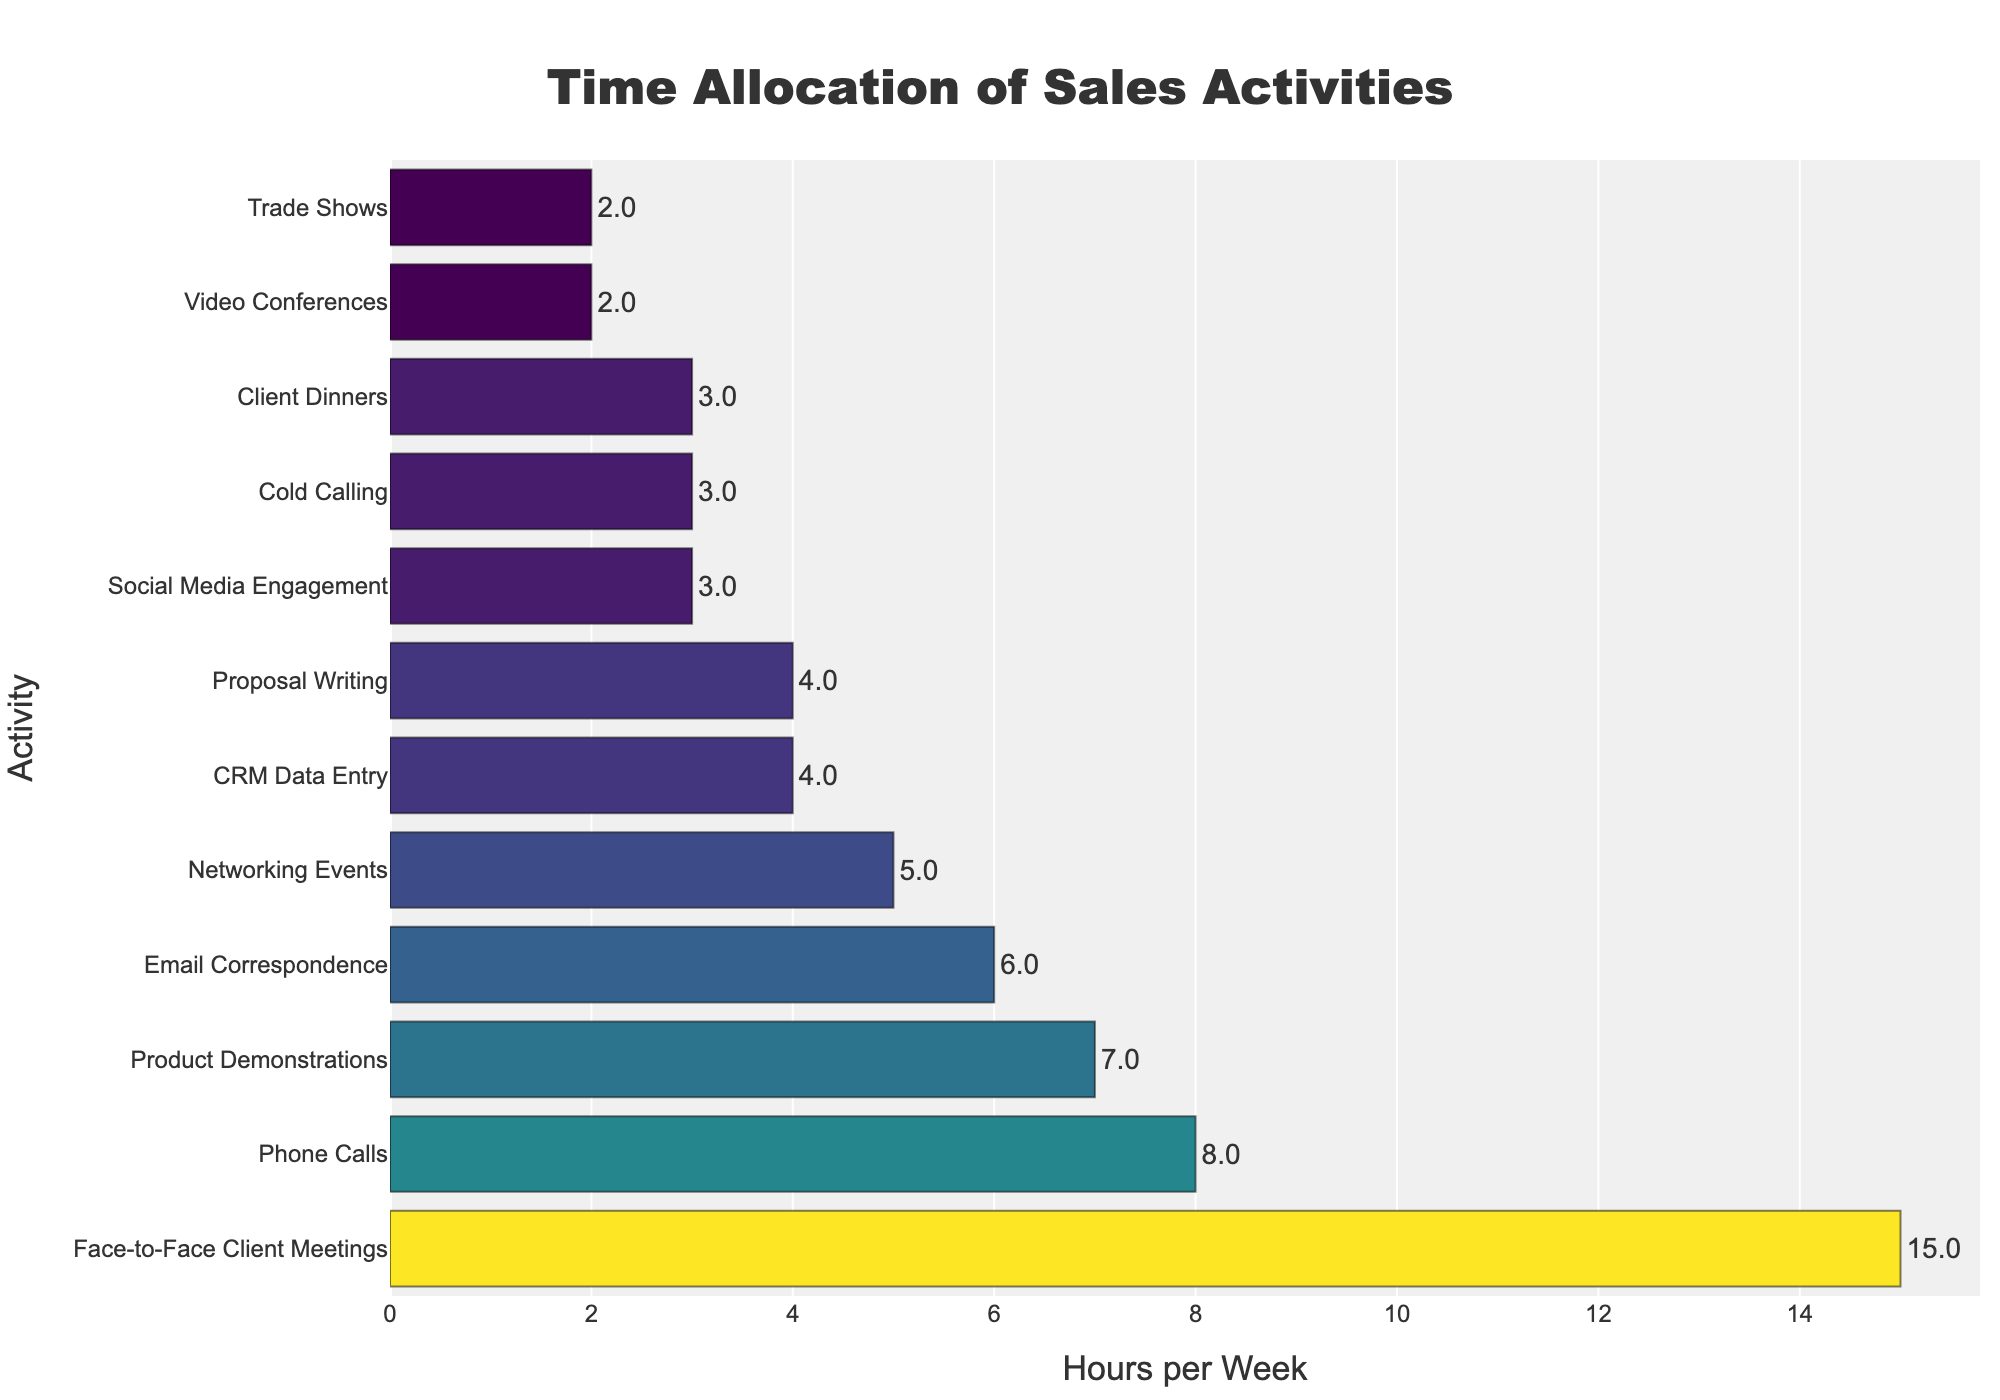Which sales activity takes up the most hours per week? The bar representing "Face-to-Face Client Meetings" is the longest, indicating it consumes the most hours per week.
Answer: Face-to-Face Client Meetings How many hours are spent on phone calls and email correspondence combined? The bar for "Phone Calls" shows 8 hours, and the bar for "Email Correspondence" shows 6 hours. Adding these together gives 8 + 6 = 14 hours.
Answer: 14 hours Which activity takes up fewer hours per week: networking events or proposal writing? The bar for "Networking Events" shows 5 hours, while the bar for "Proposal Writing" shows 4 hours. Since 4 is less than 5, proposal writing takes fewer hours per week.
Answer: Proposal Writing How many hours are allocated to face-to-face interactions (sum of client meetings, networking events, and client dinners)? The bars for "Face-to-Face Client Meetings," "Networking Events," and "Client Dinners" show 15 hours, 5 hours, and 3 hours respectively. Adding these together gives 15 + 5 + 3 = 23 hours.
Answer: 23 hours What is the difference in time allocation between product demonstrations and social media engagement? The bar for "Product Demonstrations" shows 7 hours, and the bar for "Social Media Engagement" shows 3 hours. The difference is 7 - 3 = 4 hours.
Answer: 4 hours Compare the total time spent on phone calls and cold calling versus client dinners and video conferences. The bars for "Phone Calls" and "Cold Calling" show 8 hours and 3 hours respectively (total 11 hours). The bars for "Client Dinners" and "Video Conferences" show 3 hours and 2 hours respectively (total 5 hours). Since 11 is greater than 5, more time is spent on phone calls and cold calling.
Answer: Phone Calls and Cold Calling What proportion of the total hours per week is used for client dinners? The total hours for all activities can be calculated by adding all the bars: 15 + 8 + 6 + 3 + 4 + 5 + 7 + 4 + 3 + 2 + 3 + 2 = 62 hours. The bar for "Client Dinners" shows 3 hours. The proportion is 3/62.
Answer: 3/62 What is the median time allocation per week among all the activities? Sorting the hours: 2, 2, 3, 3, 3, 4, 4, 5, 6, 7, 8, 15. The median of these 12 values is the average of the 6th and 7th values, which are both 4. Therefore, the median is (4+4)/2 = 4 hours.
Answer: 4 hours 